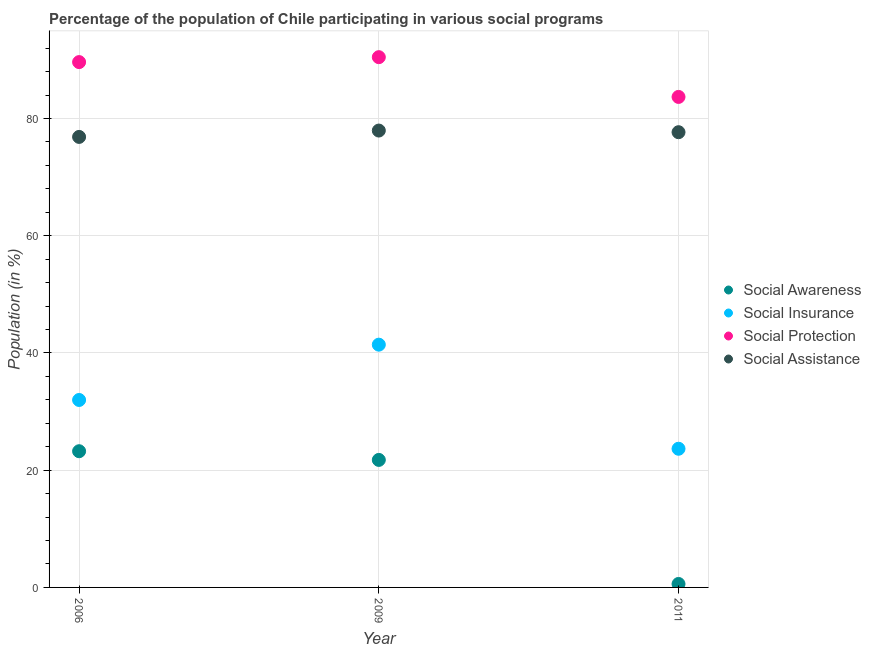Is the number of dotlines equal to the number of legend labels?
Your answer should be compact. Yes. What is the participation of population in social assistance programs in 2006?
Offer a very short reply. 76.86. Across all years, what is the maximum participation of population in social assistance programs?
Keep it short and to the point. 77.94. Across all years, what is the minimum participation of population in social assistance programs?
Your answer should be compact. 76.86. In which year was the participation of population in social awareness programs maximum?
Ensure brevity in your answer.  2006. What is the total participation of population in social assistance programs in the graph?
Provide a short and direct response. 232.46. What is the difference between the participation of population in social awareness programs in 2006 and that in 2009?
Give a very brief answer. 1.48. What is the difference between the participation of population in social awareness programs in 2011 and the participation of population in social assistance programs in 2009?
Your answer should be compact. -77.35. What is the average participation of population in social assistance programs per year?
Keep it short and to the point. 77.49. In the year 2006, what is the difference between the participation of population in social insurance programs and participation of population in social protection programs?
Provide a succinct answer. -57.64. In how many years, is the participation of population in social awareness programs greater than 40 %?
Ensure brevity in your answer.  0. What is the ratio of the participation of population in social awareness programs in 2006 to that in 2011?
Offer a terse response. 39.4. What is the difference between the highest and the second highest participation of population in social awareness programs?
Make the answer very short. 1.48. What is the difference between the highest and the lowest participation of population in social protection programs?
Keep it short and to the point. 6.78. In how many years, is the participation of population in social assistance programs greater than the average participation of population in social assistance programs taken over all years?
Provide a succinct answer. 2. Does the participation of population in social insurance programs monotonically increase over the years?
Offer a very short reply. No. Does the graph contain any zero values?
Ensure brevity in your answer.  No. How many legend labels are there?
Offer a very short reply. 4. What is the title of the graph?
Offer a terse response. Percentage of the population of Chile participating in various social programs . What is the label or title of the X-axis?
Offer a very short reply. Year. What is the label or title of the Y-axis?
Provide a short and direct response. Population (in %). What is the Population (in %) of Social Awareness in 2006?
Your response must be concise. 23.24. What is the Population (in %) of Social Insurance in 2006?
Your answer should be very brief. 31.98. What is the Population (in %) in Social Protection in 2006?
Ensure brevity in your answer.  89.62. What is the Population (in %) in Social Assistance in 2006?
Give a very brief answer. 76.86. What is the Population (in %) of Social Awareness in 2009?
Keep it short and to the point. 21.75. What is the Population (in %) of Social Insurance in 2009?
Provide a short and direct response. 41.42. What is the Population (in %) in Social Protection in 2009?
Provide a short and direct response. 90.46. What is the Population (in %) in Social Assistance in 2009?
Give a very brief answer. 77.94. What is the Population (in %) in Social Awareness in 2011?
Make the answer very short. 0.59. What is the Population (in %) of Social Insurance in 2011?
Your response must be concise. 23.66. What is the Population (in %) of Social Protection in 2011?
Offer a very short reply. 83.68. What is the Population (in %) of Social Assistance in 2011?
Keep it short and to the point. 77.66. Across all years, what is the maximum Population (in %) in Social Awareness?
Ensure brevity in your answer.  23.24. Across all years, what is the maximum Population (in %) of Social Insurance?
Offer a very short reply. 41.42. Across all years, what is the maximum Population (in %) of Social Protection?
Provide a succinct answer. 90.46. Across all years, what is the maximum Population (in %) in Social Assistance?
Your answer should be compact. 77.94. Across all years, what is the minimum Population (in %) in Social Awareness?
Your answer should be compact. 0.59. Across all years, what is the minimum Population (in %) in Social Insurance?
Offer a very short reply. 23.66. Across all years, what is the minimum Population (in %) in Social Protection?
Ensure brevity in your answer.  83.68. Across all years, what is the minimum Population (in %) of Social Assistance?
Your answer should be very brief. 76.86. What is the total Population (in %) in Social Awareness in the graph?
Provide a short and direct response. 45.58. What is the total Population (in %) of Social Insurance in the graph?
Offer a terse response. 97.05. What is the total Population (in %) of Social Protection in the graph?
Provide a short and direct response. 263.76. What is the total Population (in %) in Social Assistance in the graph?
Your answer should be compact. 232.46. What is the difference between the Population (in %) of Social Awareness in 2006 and that in 2009?
Make the answer very short. 1.48. What is the difference between the Population (in %) in Social Insurance in 2006 and that in 2009?
Your answer should be compact. -9.44. What is the difference between the Population (in %) of Social Protection in 2006 and that in 2009?
Your response must be concise. -0.84. What is the difference between the Population (in %) of Social Assistance in 2006 and that in 2009?
Provide a short and direct response. -1.08. What is the difference between the Population (in %) in Social Awareness in 2006 and that in 2011?
Offer a very short reply. 22.65. What is the difference between the Population (in %) of Social Insurance in 2006 and that in 2011?
Ensure brevity in your answer.  8.32. What is the difference between the Population (in %) of Social Protection in 2006 and that in 2011?
Your answer should be compact. 5.94. What is the difference between the Population (in %) of Social Assistance in 2006 and that in 2011?
Your response must be concise. -0.81. What is the difference between the Population (in %) in Social Awareness in 2009 and that in 2011?
Provide a succinct answer. 21.16. What is the difference between the Population (in %) in Social Insurance in 2009 and that in 2011?
Ensure brevity in your answer.  17.76. What is the difference between the Population (in %) in Social Protection in 2009 and that in 2011?
Keep it short and to the point. 6.78. What is the difference between the Population (in %) of Social Assistance in 2009 and that in 2011?
Provide a succinct answer. 0.28. What is the difference between the Population (in %) in Social Awareness in 2006 and the Population (in %) in Social Insurance in 2009?
Offer a terse response. -18.18. What is the difference between the Population (in %) in Social Awareness in 2006 and the Population (in %) in Social Protection in 2009?
Ensure brevity in your answer.  -67.23. What is the difference between the Population (in %) of Social Awareness in 2006 and the Population (in %) of Social Assistance in 2009?
Provide a short and direct response. -54.7. What is the difference between the Population (in %) of Social Insurance in 2006 and the Population (in %) of Social Protection in 2009?
Your answer should be very brief. -58.48. What is the difference between the Population (in %) in Social Insurance in 2006 and the Population (in %) in Social Assistance in 2009?
Keep it short and to the point. -45.96. What is the difference between the Population (in %) of Social Protection in 2006 and the Population (in %) of Social Assistance in 2009?
Ensure brevity in your answer.  11.68. What is the difference between the Population (in %) in Social Awareness in 2006 and the Population (in %) in Social Insurance in 2011?
Ensure brevity in your answer.  -0.42. What is the difference between the Population (in %) of Social Awareness in 2006 and the Population (in %) of Social Protection in 2011?
Your answer should be compact. -60.44. What is the difference between the Population (in %) in Social Awareness in 2006 and the Population (in %) in Social Assistance in 2011?
Provide a succinct answer. -54.43. What is the difference between the Population (in %) in Social Insurance in 2006 and the Population (in %) in Social Protection in 2011?
Ensure brevity in your answer.  -51.7. What is the difference between the Population (in %) of Social Insurance in 2006 and the Population (in %) of Social Assistance in 2011?
Offer a very short reply. -45.68. What is the difference between the Population (in %) of Social Protection in 2006 and the Population (in %) of Social Assistance in 2011?
Give a very brief answer. 11.96. What is the difference between the Population (in %) in Social Awareness in 2009 and the Population (in %) in Social Insurance in 2011?
Offer a terse response. -1.9. What is the difference between the Population (in %) in Social Awareness in 2009 and the Population (in %) in Social Protection in 2011?
Offer a terse response. -61.93. What is the difference between the Population (in %) of Social Awareness in 2009 and the Population (in %) of Social Assistance in 2011?
Offer a very short reply. -55.91. What is the difference between the Population (in %) in Social Insurance in 2009 and the Population (in %) in Social Protection in 2011?
Provide a succinct answer. -42.26. What is the difference between the Population (in %) in Social Insurance in 2009 and the Population (in %) in Social Assistance in 2011?
Provide a succinct answer. -36.25. What is the difference between the Population (in %) in Social Protection in 2009 and the Population (in %) in Social Assistance in 2011?
Offer a very short reply. 12.8. What is the average Population (in %) in Social Awareness per year?
Provide a succinct answer. 15.19. What is the average Population (in %) in Social Insurance per year?
Keep it short and to the point. 32.35. What is the average Population (in %) of Social Protection per year?
Offer a very short reply. 87.92. What is the average Population (in %) of Social Assistance per year?
Offer a terse response. 77.49. In the year 2006, what is the difference between the Population (in %) in Social Awareness and Population (in %) in Social Insurance?
Give a very brief answer. -8.74. In the year 2006, what is the difference between the Population (in %) in Social Awareness and Population (in %) in Social Protection?
Your answer should be compact. -66.38. In the year 2006, what is the difference between the Population (in %) in Social Awareness and Population (in %) in Social Assistance?
Your response must be concise. -53.62. In the year 2006, what is the difference between the Population (in %) in Social Insurance and Population (in %) in Social Protection?
Your answer should be very brief. -57.64. In the year 2006, what is the difference between the Population (in %) of Social Insurance and Population (in %) of Social Assistance?
Make the answer very short. -44.88. In the year 2006, what is the difference between the Population (in %) in Social Protection and Population (in %) in Social Assistance?
Keep it short and to the point. 12.76. In the year 2009, what is the difference between the Population (in %) of Social Awareness and Population (in %) of Social Insurance?
Provide a short and direct response. -19.66. In the year 2009, what is the difference between the Population (in %) in Social Awareness and Population (in %) in Social Protection?
Your response must be concise. -68.71. In the year 2009, what is the difference between the Population (in %) of Social Awareness and Population (in %) of Social Assistance?
Keep it short and to the point. -56.19. In the year 2009, what is the difference between the Population (in %) in Social Insurance and Population (in %) in Social Protection?
Offer a very short reply. -49.05. In the year 2009, what is the difference between the Population (in %) of Social Insurance and Population (in %) of Social Assistance?
Your response must be concise. -36.53. In the year 2009, what is the difference between the Population (in %) in Social Protection and Population (in %) in Social Assistance?
Give a very brief answer. 12.52. In the year 2011, what is the difference between the Population (in %) in Social Awareness and Population (in %) in Social Insurance?
Your response must be concise. -23.07. In the year 2011, what is the difference between the Population (in %) of Social Awareness and Population (in %) of Social Protection?
Provide a short and direct response. -83.09. In the year 2011, what is the difference between the Population (in %) in Social Awareness and Population (in %) in Social Assistance?
Your response must be concise. -77.07. In the year 2011, what is the difference between the Population (in %) in Social Insurance and Population (in %) in Social Protection?
Make the answer very short. -60.02. In the year 2011, what is the difference between the Population (in %) in Social Insurance and Population (in %) in Social Assistance?
Provide a succinct answer. -54. In the year 2011, what is the difference between the Population (in %) in Social Protection and Population (in %) in Social Assistance?
Give a very brief answer. 6.02. What is the ratio of the Population (in %) in Social Awareness in 2006 to that in 2009?
Offer a terse response. 1.07. What is the ratio of the Population (in %) of Social Insurance in 2006 to that in 2009?
Keep it short and to the point. 0.77. What is the ratio of the Population (in %) in Social Assistance in 2006 to that in 2009?
Provide a succinct answer. 0.99. What is the ratio of the Population (in %) of Social Awareness in 2006 to that in 2011?
Your answer should be compact. 39.4. What is the ratio of the Population (in %) of Social Insurance in 2006 to that in 2011?
Ensure brevity in your answer.  1.35. What is the ratio of the Population (in %) of Social Protection in 2006 to that in 2011?
Give a very brief answer. 1.07. What is the ratio of the Population (in %) in Social Assistance in 2006 to that in 2011?
Provide a short and direct response. 0.99. What is the ratio of the Population (in %) in Social Awareness in 2009 to that in 2011?
Your answer should be very brief. 36.88. What is the ratio of the Population (in %) of Social Insurance in 2009 to that in 2011?
Ensure brevity in your answer.  1.75. What is the ratio of the Population (in %) of Social Protection in 2009 to that in 2011?
Give a very brief answer. 1.08. What is the difference between the highest and the second highest Population (in %) in Social Awareness?
Provide a succinct answer. 1.48. What is the difference between the highest and the second highest Population (in %) in Social Insurance?
Provide a succinct answer. 9.44. What is the difference between the highest and the second highest Population (in %) in Social Protection?
Your response must be concise. 0.84. What is the difference between the highest and the second highest Population (in %) in Social Assistance?
Keep it short and to the point. 0.28. What is the difference between the highest and the lowest Population (in %) in Social Awareness?
Your response must be concise. 22.65. What is the difference between the highest and the lowest Population (in %) in Social Insurance?
Your answer should be very brief. 17.76. What is the difference between the highest and the lowest Population (in %) in Social Protection?
Your answer should be very brief. 6.78. What is the difference between the highest and the lowest Population (in %) in Social Assistance?
Your answer should be very brief. 1.08. 